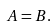<formula> <loc_0><loc_0><loc_500><loc_500>A = B .</formula> 